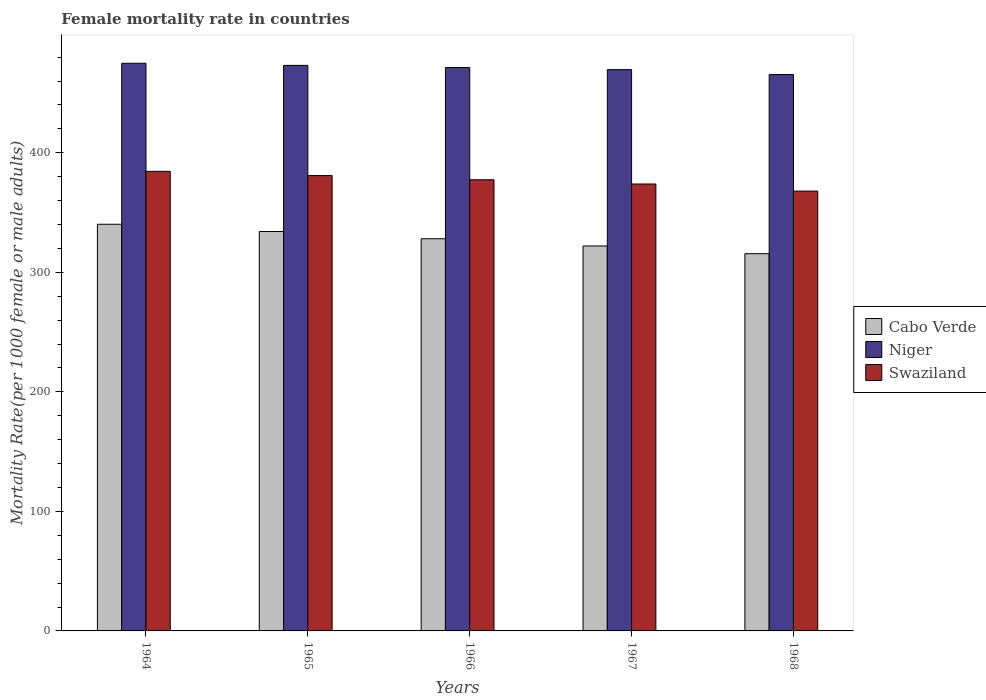How many different coloured bars are there?
Your answer should be compact. 3. How many groups of bars are there?
Provide a short and direct response. 5. Are the number of bars per tick equal to the number of legend labels?
Give a very brief answer. Yes. Are the number of bars on each tick of the X-axis equal?
Your response must be concise. Yes. How many bars are there on the 1st tick from the left?
Your answer should be very brief. 3. How many bars are there on the 1st tick from the right?
Provide a short and direct response. 3. What is the label of the 4th group of bars from the left?
Your response must be concise. 1967. In how many cases, is the number of bars for a given year not equal to the number of legend labels?
Provide a succinct answer. 0. What is the female mortality rate in Cabo Verde in 1967?
Your answer should be compact. 322.05. Across all years, what is the maximum female mortality rate in Niger?
Offer a very short reply. 474.91. Across all years, what is the minimum female mortality rate in Niger?
Your answer should be compact. 465.45. In which year was the female mortality rate in Swaziland maximum?
Your response must be concise. 1964. In which year was the female mortality rate in Cabo Verde minimum?
Offer a very short reply. 1968. What is the total female mortality rate in Cabo Verde in the graph?
Offer a terse response. 1640.1. What is the difference between the female mortality rate in Swaziland in 1964 and that in 1966?
Give a very brief answer. 7.06. What is the difference between the female mortality rate in Cabo Verde in 1965 and the female mortality rate in Swaziland in 1966?
Ensure brevity in your answer.  -43.26. What is the average female mortality rate in Swaziland per year?
Your answer should be compact. 376.94. In the year 1967, what is the difference between the female mortality rate in Niger and female mortality rate in Cabo Verde?
Offer a terse response. 147.54. What is the ratio of the female mortality rate in Cabo Verde in 1964 to that in 1968?
Your answer should be compact. 1.08. What is the difference between the highest and the second highest female mortality rate in Cabo Verde?
Your answer should be compact. 6.06. What is the difference between the highest and the lowest female mortality rate in Cabo Verde?
Your answer should be very brief. 24.63. In how many years, is the female mortality rate in Niger greater than the average female mortality rate in Niger taken over all years?
Ensure brevity in your answer.  3. What does the 3rd bar from the left in 1964 represents?
Your answer should be very brief. Swaziland. What does the 1st bar from the right in 1965 represents?
Ensure brevity in your answer.  Swaziland. How many bars are there?
Your answer should be compact. 15. Are all the bars in the graph horizontal?
Offer a terse response. No. What is the difference between two consecutive major ticks on the Y-axis?
Make the answer very short. 100. Are the values on the major ticks of Y-axis written in scientific E-notation?
Your answer should be compact. No. Does the graph contain grids?
Your answer should be compact. No. How many legend labels are there?
Your response must be concise. 3. What is the title of the graph?
Provide a succinct answer. Female mortality rate in countries. Does "Puerto Rico" appear as one of the legend labels in the graph?
Offer a terse response. No. What is the label or title of the Y-axis?
Provide a short and direct response. Mortality Rate(per 1000 female or male adults). What is the Mortality Rate(per 1000 female or male adults) of Cabo Verde in 1964?
Offer a terse response. 340.21. What is the Mortality Rate(per 1000 female or male adults) of Niger in 1964?
Ensure brevity in your answer.  474.91. What is the Mortality Rate(per 1000 female or male adults) of Swaziland in 1964?
Provide a succinct answer. 384.48. What is the Mortality Rate(per 1000 female or male adults) in Cabo Verde in 1965?
Your response must be concise. 334.16. What is the Mortality Rate(per 1000 female or male adults) in Niger in 1965?
Ensure brevity in your answer.  473.13. What is the Mortality Rate(per 1000 female or male adults) in Swaziland in 1965?
Your answer should be compact. 380.95. What is the Mortality Rate(per 1000 female or male adults) in Cabo Verde in 1966?
Offer a terse response. 328.1. What is the Mortality Rate(per 1000 female or male adults) in Niger in 1966?
Make the answer very short. 471.36. What is the Mortality Rate(per 1000 female or male adults) in Swaziland in 1966?
Your answer should be very brief. 377.42. What is the Mortality Rate(per 1000 female or male adults) of Cabo Verde in 1967?
Give a very brief answer. 322.05. What is the Mortality Rate(per 1000 female or male adults) of Niger in 1967?
Make the answer very short. 469.59. What is the Mortality Rate(per 1000 female or male adults) in Swaziland in 1967?
Make the answer very short. 373.89. What is the Mortality Rate(per 1000 female or male adults) in Cabo Verde in 1968?
Ensure brevity in your answer.  315.58. What is the Mortality Rate(per 1000 female or male adults) in Niger in 1968?
Ensure brevity in your answer.  465.45. What is the Mortality Rate(per 1000 female or male adults) of Swaziland in 1968?
Offer a terse response. 367.96. Across all years, what is the maximum Mortality Rate(per 1000 female or male adults) of Cabo Verde?
Keep it short and to the point. 340.21. Across all years, what is the maximum Mortality Rate(per 1000 female or male adults) of Niger?
Make the answer very short. 474.91. Across all years, what is the maximum Mortality Rate(per 1000 female or male adults) of Swaziland?
Give a very brief answer. 384.48. Across all years, what is the minimum Mortality Rate(per 1000 female or male adults) of Cabo Verde?
Ensure brevity in your answer.  315.58. Across all years, what is the minimum Mortality Rate(per 1000 female or male adults) of Niger?
Give a very brief answer. 465.45. Across all years, what is the minimum Mortality Rate(per 1000 female or male adults) of Swaziland?
Ensure brevity in your answer.  367.96. What is the total Mortality Rate(per 1000 female or male adults) in Cabo Verde in the graph?
Provide a short and direct response. 1640.1. What is the total Mortality Rate(per 1000 female or male adults) in Niger in the graph?
Your answer should be compact. 2354.44. What is the total Mortality Rate(per 1000 female or male adults) of Swaziland in the graph?
Your response must be concise. 1884.71. What is the difference between the Mortality Rate(per 1000 female or male adults) of Cabo Verde in 1964 and that in 1965?
Your response must be concise. 6.06. What is the difference between the Mortality Rate(per 1000 female or male adults) in Niger in 1964 and that in 1965?
Provide a succinct answer. 1.77. What is the difference between the Mortality Rate(per 1000 female or male adults) of Swaziland in 1964 and that in 1965?
Your response must be concise. 3.53. What is the difference between the Mortality Rate(per 1000 female or male adults) of Cabo Verde in 1964 and that in 1966?
Your response must be concise. 12.11. What is the difference between the Mortality Rate(per 1000 female or male adults) of Niger in 1964 and that in 1966?
Offer a very short reply. 3.54. What is the difference between the Mortality Rate(per 1000 female or male adults) of Swaziland in 1964 and that in 1966?
Provide a short and direct response. 7.05. What is the difference between the Mortality Rate(per 1000 female or male adults) of Cabo Verde in 1964 and that in 1967?
Offer a terse response. 18.17. What is the difference between the Mortality Rate(per 1000 female or male adults) in Niger in 1964 and that in 1967?
Offer a very short reply. 5.32. What is the difference between the Mortality Rate(per 1000 female or male adults) in Swaziland in 1964 and that in 1967?
Your answer should be compact. 10.58. What is the difference between the Mortality Rate(per 1000 female or male adults) of Cabo Verde in 1964 and that in 1968?
Your response must be concise. 24.63. What is the difference between the Mortality Rate(per 1000 female or male adults) in Niger in 1964 and that in 1968?
Offer a terse response. 9.46. What is the difference between the Mortality Rate(per 1000 female or male adults) of Swaziland in 1964 and that in 1968?
Offer a very short reply. 16.52. What is the difference between the Mortality Rate(per 1000 female or male adults) in Cabo Verde in 1965 and that in 1966?
Provide a short and direct response. 6.06. What is the difference between the Mortality Rate(per 1000 female or male adults) of Niger in 1965 and that in 1966?
Offer a terse response. 1.77. What is the difference between the Mortality Rate(per 1000 female or male adults) of Swaziland in 1965 and that in 1966?
Ensure brevity in your answer.  3.53. What is the difference between the Mortality Rate(per 1000 female or male adults) of Cabo Verde in 1965 and that in 1967?
Ensure brevity in your answer.  12.11. What is the difference between the Mortality Rate(per 1000 female or male adults) in Niger in 1965 and that in 1967?
Keep it short and to the point. 3.54. What is the difference between the Mortality Rate(per 1000 female or male adults) of Swaziland in 1965 and that in 1967?
Your response must be concise. 7.05. What is the difference between the Mortality Rate(per 1000 female or male adults) in Cabo Verde in 1965 and that in 1968?
Ensure brevity in your answer.  18.57. What is the difference between the Mortality Rate(per 1000 female or male adults) in Niger in 1965 and that in 1968?
Provide a short and direct response. 7.68. What is the difference between the Mortality Rate(per 1000 female or male adults) in Swaziland in 1965 and that in 1968?
Your answer should be very brief. 12.99. What is the difference between the Mortality Rate(per 1000 female or male adults) of Cabo Verde in 1966 and that in 1967?
Provide a short and direct response. 6.06. What is the difference between the Mortality Rate(per 1000 female or male adults) of Niger in 1966 and that in 1967?
Offer a terse response. 1.77. What is the difference between the Mortality Rate(per 1000 female or male adults) of Swaziland in 1966 and that in 1967?
Keep it short and to the point. 3.53. What is the difference between the Mortality Rate(per 1000 female or male adults) of Cabo Verde in 1966 and that in 1968?
Offer a terse response. 12.52. What is the difference between the Mortality Rate(per 1000 female or male adults) of Niger in 1966 and that in 1968?
Provide a short and direct response. 5.91. What is the difference between the Mortality Rate(per 1000 female or male adults) of Swaziland in 1966 and that in 1968?
Provide a short and direct response. 9.46. What is the difference between the Mortality Rate(per 1000 female or male adults) of Cabo Verde in 1967 and that in 1968?
Provide a succinct answer. 6.46. What is the difference between the Mortality Rate(per 1000 female or male adults) in Niger in 1967 and that in 1968?
Offer a very short reply. 4.14. What is the difference between the Mortality Rate(per 1000 female or male adults) of Swaziland in 1967 and that in 1968?
Provide a succinct answer. 5.93. What is the difference between the Mortality Rate(per 1000 female or male adults) of Cabo Verde in 1964 and the Mortality Rate(per 1000 female or male adults) of Niger in 1965?
Provide a succinct answer. -132.92. What is the difference between the Mortality Rate(per 1000 female or male adults) in Cabo Verde in 1964 and the Mortality Rate(per 1000 female or male adults) in Swaziland in 1965?
Provide a short and direct response. -40.74. What is the difference between the Mortality Rate(per 1000 female or male adults) in Niger in 1964 and the Mortality Rate(per 1000 female or male adults) in Swaziland in 1965?
Offer a very short reply. 93.96. What is the difference between the Mortality Rate(per 1000 female or male adults) in Cabo Verde in 1964 and the Mortality Rate(per 1000 female or male adults) in Niger in 1966?
Offer a terse response. -131.15. What is the difference between the Mortality Rate(per 1000 female or male adults) of Cabo Verde in 1964 and the Mortality Rate(per 1000 female or male adults) of Swaziland in 1966?
Give a very brief answer. -37.21. What is the difference between the Mortality Rate(per 1000 female or male adults) in Niger in 1964 and the Mortality Rate(per 1000 female or male adults) in Swaziland in 1966?
Keep it short and to the point. 97.48. What is the difference between the Mortality Rate(per 1000 female or male adults) in Cabo Verde in 1964 and the Mortality Rate(per 1000 female or male adults) in Niger in 1967?
Give a very brief answer. -129.38. What is the difference between the Mortality Rate(per 1000 female or male adults) of Cabo Verde in 1964 and the Mortality Rate(per 1000 female or male adults) of Swaziland in 1967?
Keep it short and to the point. -33.68. What is the difference between the Mortality Rate(per 1000 female or male adults) of Niger in 1964 and the Mortality Rate(per 1000 female or male adults) of Swaziland in 1967?
Your answer should be very brief. 101.01. What is the difference between the Mortality Rate(per 1000 female or male adults) of Cabo Verde in 1964 and the Mortality Rate(per 1000 female or male adults) of Niger in 1968?
Ensure brevity in your answer.  -125.24. What is the difference between the Mortality Rate(per 1000 female or male adults) in Cabo Verde in 1964 and the Mortality Rate(per 1000 female or male adults) in Swaziland in 1968?
Provide a succinct answer. -27.75. What is the difference between the Mortality Rate(per 1000 female or male adults) of Niger in 1964 and the Mortality Rate(per 1000 female or male adults) of Swaziland in 1968?
Your answer should be compact. 106.94. What is the difference between the Mortality Rate(per 1000 female or male adults) in Cabo Verde in 1965 and the Mortality Rate(per 1000 female or male adults) in Niger in 1966?
Your answer should be very brief. -137.2. What is the difference between the Mortality Rate(per 1000 female or male adults) in Cabo Verde in 1965 and the Mortality Rate(per 1000 female or male adults) in Swaziland in 1966?
Your response must be concise. -43.27. What is the difference between the Mortality Rate(per 1000 female or male adults) in Niger in 1965 and the Mortality Rate(per 1000 female or male adults) in Swaziland in 1966?
Your answer should be very brief. 95.71. What is the difference between the Mortality Rate(per 1000 female or male adults) of Cabo Verde in 1965 and the Mortality Rate(per 1000 female or male adults) of Niger in 1967?
Keep it short and to the point. -135.43. What is the difference between the Mortality Rate(per 1000 female or male adults) in Cabo Verde in 1965 and the Mortality Rate(per 1000 female or male adults) in Swaziland in 1967?
Your answer should be very brief. -39.74. What is the difference between the Mortality Rate(per 1000 female or male adults) in Niger in 1965 and the Mortality Rate(per 1000 female or male adults) in Swaziland in 1967?
Your answer should be very brief. 99.24. What is the difference between the Mortality Rate(per 1000 female or male adults) of Cabo Verde in 1965 and the Mortality Rate(per 1000 female or male adults) of Niger in 1968?
Your answer should be compact. -131.29. What is the difference between the Mortality Rate(per 1000 female or male adults) of Cabo Verde in 1965 and the Mortality Rate(per 1000 female or male adults) of Swaziland in 1968?
Provide a succinct answer. -33.8. What is the difference between the Mortality Rate(per 1000 female or male adults) in Niger in 1965 and the Mortality Rate(per 1000 female or male adults) in Swaziland in 1968?
Offer a terse response. 105.17. What is the difference between the Mortality Rate(per 1000 female or male adults) of Cabo Verde in 1966 and the Mortality Rate(per 1000 female or male adults) of Niger in 1967?
Your response must be concise. -141.49. What is the difference between the Mortality Rate(per 1000 female or male adults) of Cabo Verde in 1966 and the Mortality Rate(per 1000 female or male adults) of Swaziland in 1967?
Provide a short and direct response. -45.79. What is the difference between the Mortality Rate(per 1000 female or male adults) of Niger in 1966 and the Mortality Rate(per 1000 female or male adults) of Swaziland in 1967?
Provide a succinct answer. 97.47. What is the difference between the Mortality Rate(per 1000 female or male adults) of Cabo Verde in 1966 and the Mortality Rate(per 1000 female or male adults) of Niger in 1968?
Ensure brevity in your answer.  -137.35. What is the difference between the Mortality Rate(per 1000 female or male adults) in Cabo Verde in 1966 and the Mortality Rate(per 1000 female or male adults) in Swaziland in 1968?
Your answer should be compact. -39.86. What is the difference between the Mortality Rate(per 1000 female or male adults) in Niger in 1966 and the Mortality Rate(per 1000 female or male adults) in Swaziland in 1968?
Give a very brief answer. 103.4. What is the difference between the Mortality Rate(per 1000 female or male adults) of Cabo Verde in 1967 and the Mortality Rate(per 1000 female or male adults) of Niger in 1968?
Your response must be concise. -143.41. What is the difference between the Mortality Rate(per 1000 female or male adults) of Cabo Verde in 1967 and the Mortality Rate(per 1000 female or male adults) of Swaziland in 1968?
Your response must be concise. -45.92. What is the difference between the Mortality Rate(per 1000 female or male adults) of Niger in 1967 and the Mortality Rate(per 1000 female or male adults) of Swaziland in 1968?
Your response must be concise. 101.63. What is the average Mortality Rate(per 1000 female or male adults) in Cabo Verde per year?
Keep it short and to the point. 328.02. What is the average Mortality Rate(per 1000 female or male adults) in Niger per year?
Offer a very short reply. 470.89. What is the average Mortality Rate(per 1000 female or male adults) in Swaziland per year?
Offer a terse response. 376.94. In the year 1964, what is the difference between the Mortality Rate(per 1000 female or male adults) of Cabo Verde and Mortality Rate(per 1000 female or male adults) of Niger?
Your answer should be compact. -134.69. In the year 1964, what is the difference between the Mortality Rate(per 1000 female or male adults) of Cabo Verde and Mortality Rate(per 1000 female or male adults) of Swaziland?
Provide a succinct answer. -44.26. In the year 1964, what is the difference between the Mortality Rate(per 1000 female or male adults) of Niger and Mortality Rate(per 1000 female or male adults) of Swaziland?
Give a very brief answer. 90.43. In the year 1965, what is the difference between the Mortality Rate(per 1000 female or male adults) in Cabo Verde and Mortality Rate(per 1000 female or male adults) in Niger?
Provide a succinct answer. -138.98. In the year 1965, what is the difference between the Mortality Rate(per 1000 female or male adults) in Cabo Verde and Mortality Rate(per 1000 female or male adults) in Swaziland?
Provide a short and direct response. -46.79. In the year 1965, what is the difference between the Mortality Rate(per 1000 female or male adults) of Niger and Mortality Rate(per 1000 female or male adults) of Swaziland?
Provide a short and direct response. 92.18. In the year 1966, what is the difference between the Mortality Rate(per 1000 female or male adults) of Cabo Verde and Mortality Rate(per 1000 female or male adults) of Niger?
Keep it short and to the point. -143.26. In the year 1966, what is the difference between the Mortality Rate(per 1000 female or male adults) in Cabo Verde and Mortality Rate(per 1000 female or male adults) in Swaziland?
Give a very brief answer. -49.32. In the year 1966, what is the difference between the Mortality Rate(per 1000 female or male adults) in Niger and Mortality Rate(per 1000 female or male adults) in Swaziland?
Provide a short and direct response. 93.94. In the year 1967, what is the difference between the Mortality Rate(per 1000 female or male adults) of Cabo Verde and Mortality Rate(per 1000 female or male adults) of Niger?
Offer a terse response. -147.54. In the year 1967, what is the difference between the Mortality Rate(per 1000 female or male adults) in Cabo Verde and Mortality Rate(per 1000 female or male adults) in Swaziland?
Your answer should be very brief. -51.85. In the year 1967, what is the difference between the Mortality Rate(per 1000 female or male adults) of Niger and Mortality Rate(per 1000 female or male adults) of Swaziland?
Your answer should be compact. 95.69. In the year 1968, what is the difference between the Mortality Rate(per 1000 female or male adults) in Cabo Verde and Mortality Rate(per 1000 female or male adults) in Niger?
Offer a very short reply. -149.87. In the year 1968, what is the difference between the Mortality Rate(per 1000 female or male adults) in Cabo Verde and Mortality Rate(per 1000 female or male adults) in Swaziland?
Keep it short and to the point. -52.38. In the year 1968, what is the difference between the Mortality Rate(per 1000 female or male adults) in Niger and Mortality Rate(per 1000 female or male adults) in Swaziland?
Keep it short and to the point. 97.49. What is the ratio of the Mortality Rate(per 1000 female or male adults) in Cabo Verde in 1964 to that in 1965?
Provide a short and direct response. 1.02. What is the ratio of the Mortality Rate(per 1000 female or male adults) in Niger in 1964 to that in 1965?
Make the answer very short. 1. What is the ratio of the Mortality Rate(per 1000 female or male adults) of Swaziland in 1964 to that in 1965?
Provide a succinct answer. 1.01. What is the ratio of the Mortality Rate(per 1000 female or male adults) in Cabo Verde in 1964 to that in 1966?
Your answer should be very brief. 1.04. What is the ratio of the Mortality Rate(per 1000 female or male adults) of Niger in 1964 to that in 1966?
Ensure brevity in your answer.  1.01. What is the ratio of the Mortality Rate(per 1000 female or male adults) in Swaziland in 1964 to that in 1966?
Provide a short and direct response. 1.02. What is the ratio of the Mortality Rate(per 1000 female or male adults) of Cabo Verde in 1964 to that in 1967?
Provide a short and direct response. 1.06. What is the ratio of the Mortality Rate(per 1000 female or male adults) of Niger in 1964 to that in 1967?
Your answer should be very brief. 1.01. What is the ratio of the Mortality Rate(per 1000 female or male adults) of Swaziland in 1964 to that in 1967?
Your response must be concise. 1.03. What is the ratio of the Mortality Rate(per 1000 female or male adults) in Cabo Verde in 1964 to that in 1968?
Provide a succinct answer. 1.08. What is the ratio of the Mortality Rate(per 1000 female or male adults) in Niger in 1964 to that in 1968?
Ensure brevity in your answer.  1.02. What is the ratio of the Mortality Rate(per 1000 female or male adults) of Swaziland in 1964 to that in 1968?
Your answer should be compact. 1.04. What is the ratio of the Mortality Rate(per 1000 female or male adults) in Cabo Verde in 1965 to that in 1966?
Give a very brief answer. 1.02. What is the ratio of the Mortality Rate(per 1000 female or male adults) in Niger in 1965 to that in 1966?
Provide a succinct answer. 1. What is the ratio of the Mortality Rate(per 1000 female or male adults) in Swaziland in 1965 to that in 1966?
Make the answer very short. 1.01. What is the ratio of the Mortality Rate(per 1000 female or male adults) in Cabo Verde in 1965 to that in 1967?
Give a very brief answer. 1.04. What is the ratio of the Mortality Rate(per 1000 female or male adults) of Niger in 1965 to that in 1967?
Provide a short and direct response. 1.01. What is the ratio of the Mortality Rate(per 1000 female or male adults) in Swaziland in 1965 to that in 1967?
Provide a short and direct response. 1.02. What is the ratio of the Mortality Rate(per 1000 female or male adults) in Cabo Verde in 1965 to that in 1968?
Make the answer very short. 1.06. What is the ratio of the Mortality Rate(per 1000 female or male adults) of Niger in 1965 to that in 1968?
Your response must be concise. 1.02. What is the ratio of the Mortality Rate(per 1000 female or male adults) in Swaziland in 1965 to that in 1968?
Give a very brief answer. 1.04. What is the ratio of the Mortality Rate(per 1000 female or male adults) in Cabo Verde in 1966 to that in 1967?
Ensure brevity in your answer.  1.02. What is the ratio of the Mortality Rate(per 1000 female or male adults) in Swaziland in 1966 to that in 1967?
Make the answer very short. 1.01. What is the ratio of the Mortality Rate(per 1000 female or male adults) in Cabo Verde in 1966 to that in 1968?
Your answer should be compact. 1.04. What is the ratio of the Mortality Rate(per 1000 female or male adults) in Niger in 1966 to that in 1968?
Provide a succinct answer. 1.01. What is the ratio of the Mortality Rate(per 1000 female or male adults) of Swaziland in 1966 to that in 1968?
Your answer should be compact. 1.03. What is the ratio of the Mortality Rate(per 1000 female or male adults) of Cabo Verde in 1967 to that in 1968?
Your answer should be compact. 1.02. What is the ratio of the Mortality Rate(per 1000 female or male adults) in Niger in 1967 to that in 1968?
Make the answer very short. 1.01. What is the ratio of the Mortality Rate(per 1000 female or male adults) of Swaziland in 1967 to that in 1968?
Your answer should be compact. 1.02. What is the difference between the highest and the second highest Mortality Rate(per 1000 female or male adults) of Cabo Verde?
Provide a short and direct response. 6.06. What is the difference between the highest and the second highest Mortality Rate(per 1000 female or male adults) in Niger?
Ensure brevity in your answer.  1.77. What is the difference between the highest and the second highest Mortality Rate(per 1000 female or male adults) of Swaziland?
Your answer should be compact. 3.53. What is the difference between the highest and the lowest Mortality Rate(per 1000 female or male adults) of Cabo Verde?
Provide a succinct answer. 24.63. What is the difference between the highest and the lowest Mortality Rate(per 1000 female or male adults) in Niger?
Your answer should be compact. 9.46. What is the difference between the highest and the lowest Mortality Rate(per 1000 female or male adults) of Swaziland?
Provide a short and direct response. 16.52. 